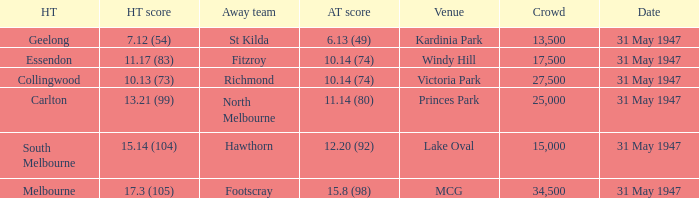What day is south melbourne at home? 31 May 1947. 